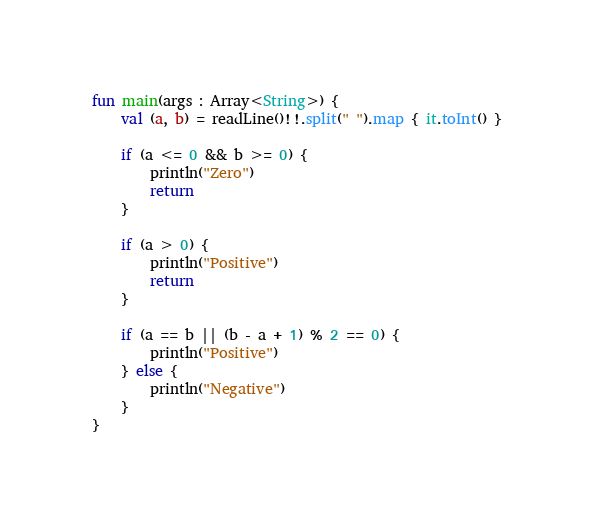Convert code to text. <code><loc_0><loc_0><loc_500><loc_500><_Kotlin_>fun main(args : Array<String>) {
    val (a, b) = readLine()!!.split(" ").map { it.toInt() }

    if (a <= 0 && b >= 0) {
        println("Zero")
        return
    }

    if (a > 0) {
        println("Positive")
        return
    }

    if (a == b || (b - a + 1) % 2 == 0) {
        println("Positive")
    } else {
        println("Negative")
    }
}</code> 